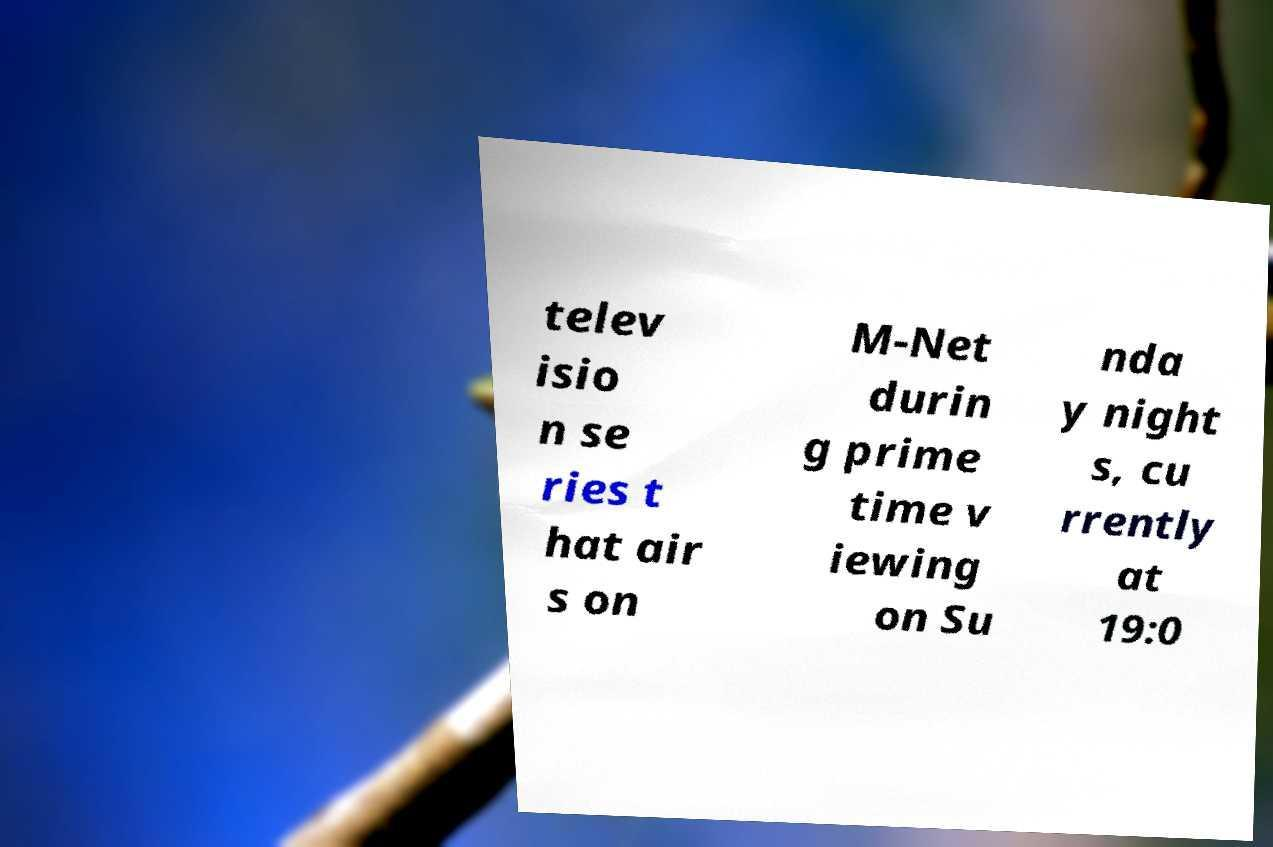Can you accurately transcribe the text from the provided image for me? telev isio n se ries t hat air s on M-Net durin g prime time v iewing on Su nda y night s, cu rrently at 19:0 